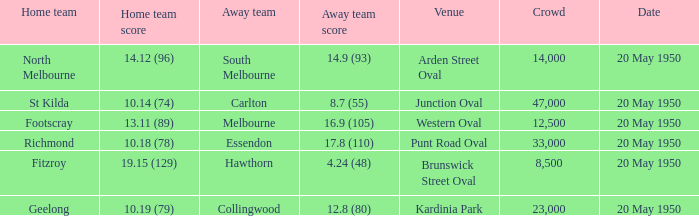What was the date of the game when the away team was south melbourne? 20 May 1950. 